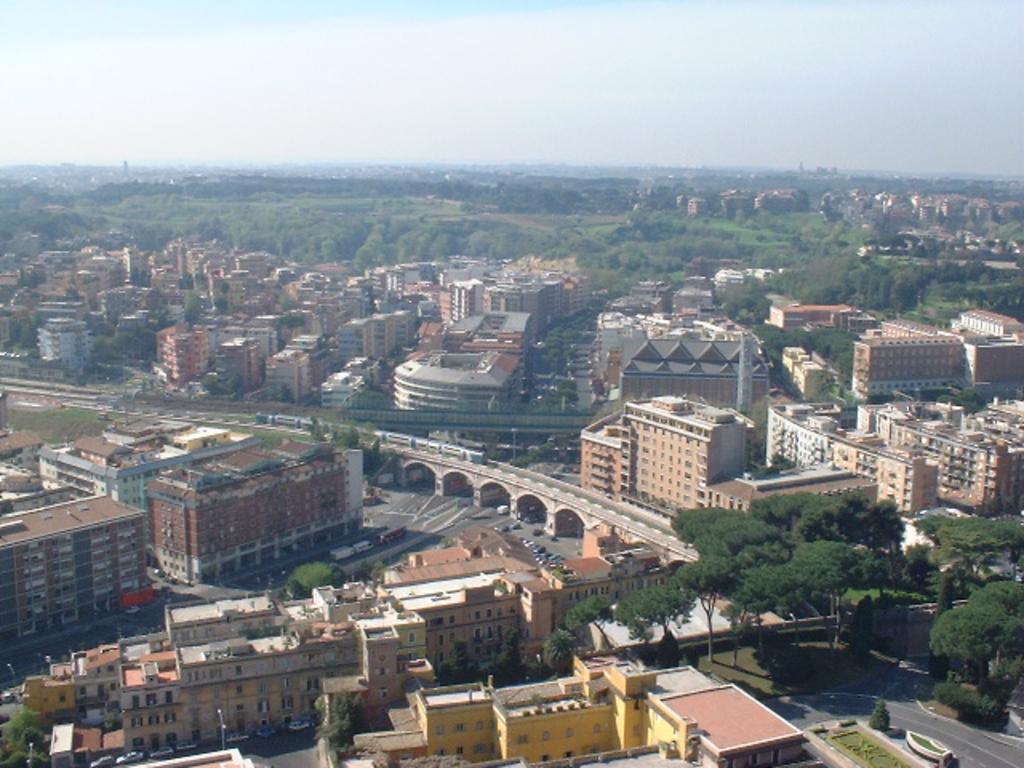How would you summarize this image in a sentence or two? In this image there are some buildings, trees and in the center there is a bridge. On the bridge there is a train and also we could see some vehicles on a road, and at the top of the image there is sky. 